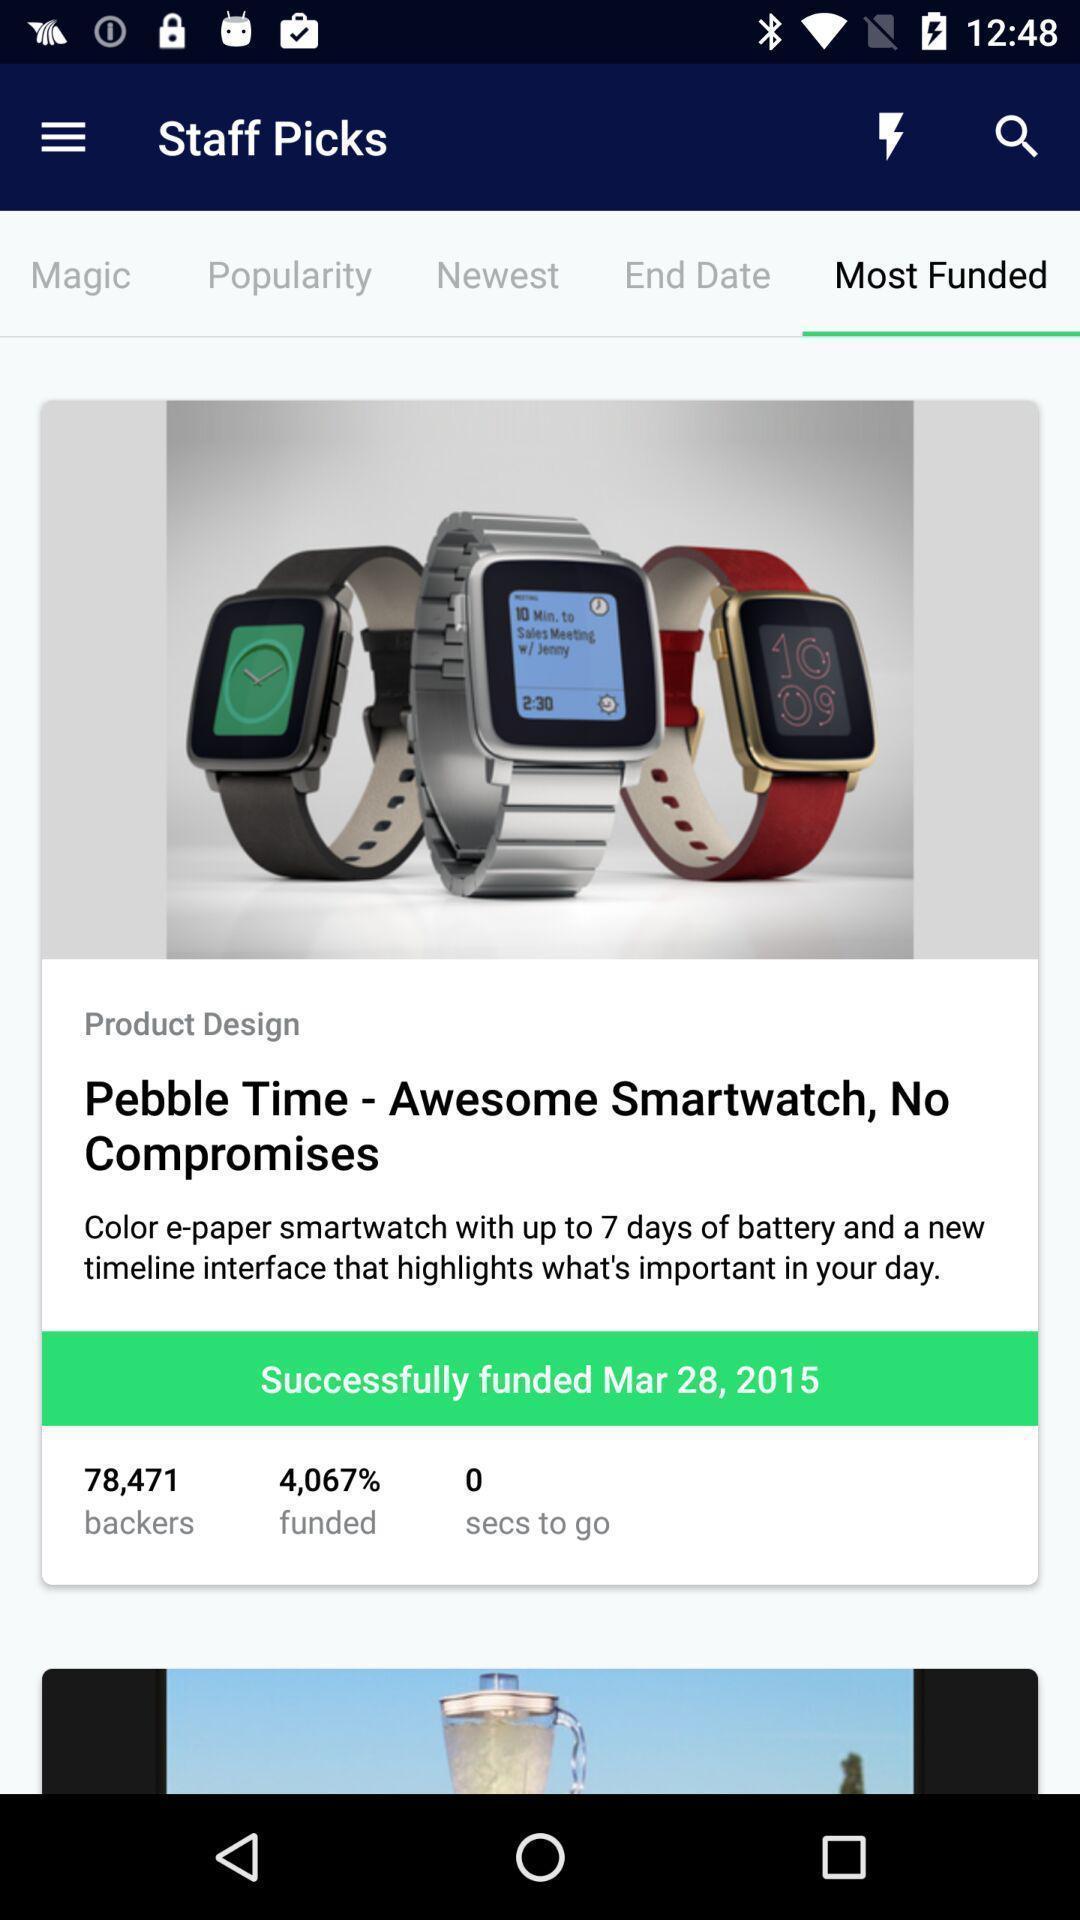Describe this image in words. Screen displaying the smart watch design. 